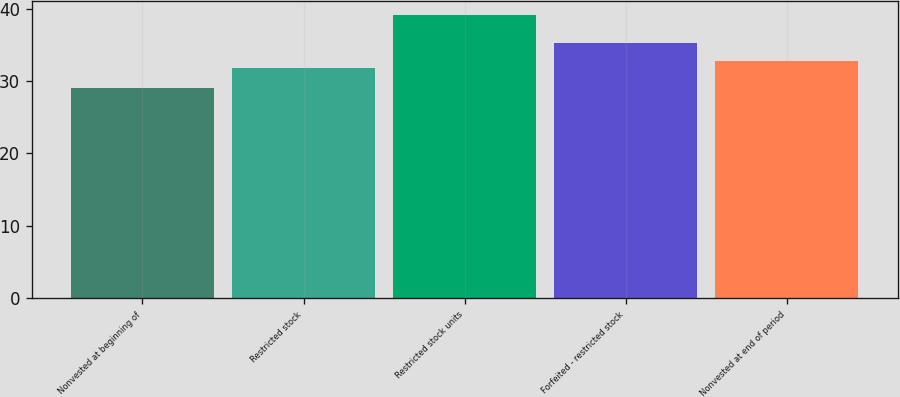<chart> <loc_0><loc_0><loc_500><loc_500><bar_chart><fcel>Nonvested at beginning of<fcel>Restricted stock<fcel>Restricted stock units<fcel>Forfeited - restricted stock<fcel>Nonvested at end of period<nl><fcel>29.08<fcel>31.74<fcel>39.12<fcel>35.18<fcel>32.74<nl></chart> 